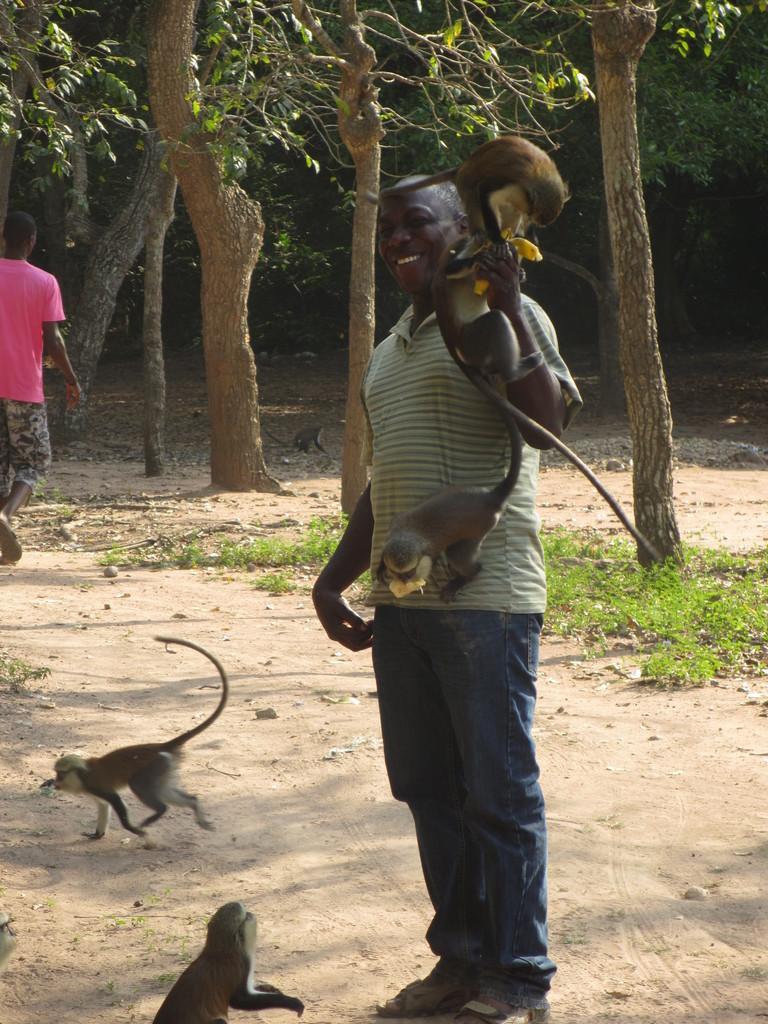Can you describe this image briefly? In this picture we can see few animals and group of people, in the background we can see few trees. 